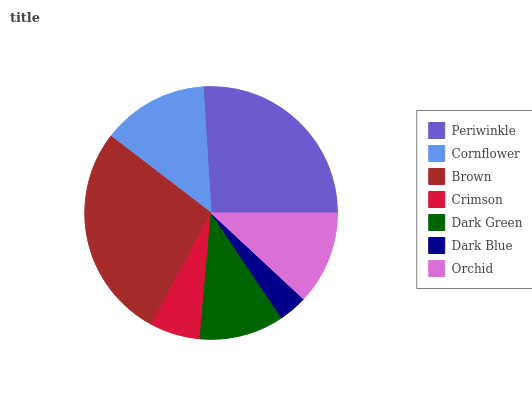Is Dark Blue the minimum?
Answer yes or no. Yes. Is Brown the maximum?
Answer yes or no. Yes. Is Cornflower the minimum?
Answer yes or no. No. Is Cornflower the maximum?
Answer yes or no. No. Is Periwinkle greater than Cornflower?
Answer yes or no. Yes. Is Cornflower less than Periwinkle?
Answer yes or no. Yes. Is Cornflower greater than Periwinkle?
Answer yes or no. No. Is Periwinkle less than Cornflower?
Answer yes or no. No. Is Orchid the high median?
Answer yes or no. Yes. Is Orchid the low median?
Answer yes or no. Yes. Is Brown the high median?
Answer yes or no. No. Is Cornflower the low median?
Answer yes or no. No. 